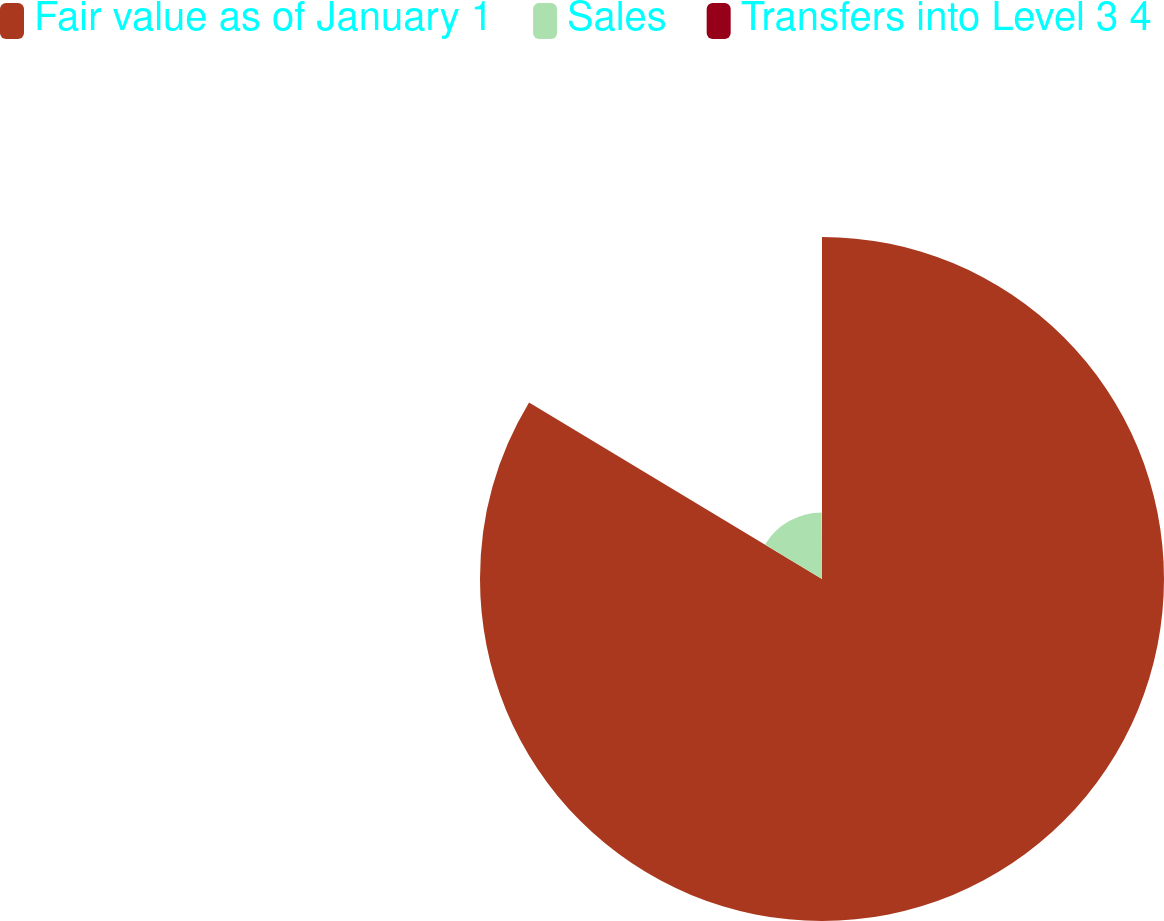<chart> <loc_0><loc_0><loc_500><loc_500><pie_chart><fcel>Fair value as of January 1<fcel>Sales<fcel>Transfers into Level 3 4<nl><fcel>83.63%<fcel>16.29%<fcel>0.08%<nl></chart> 